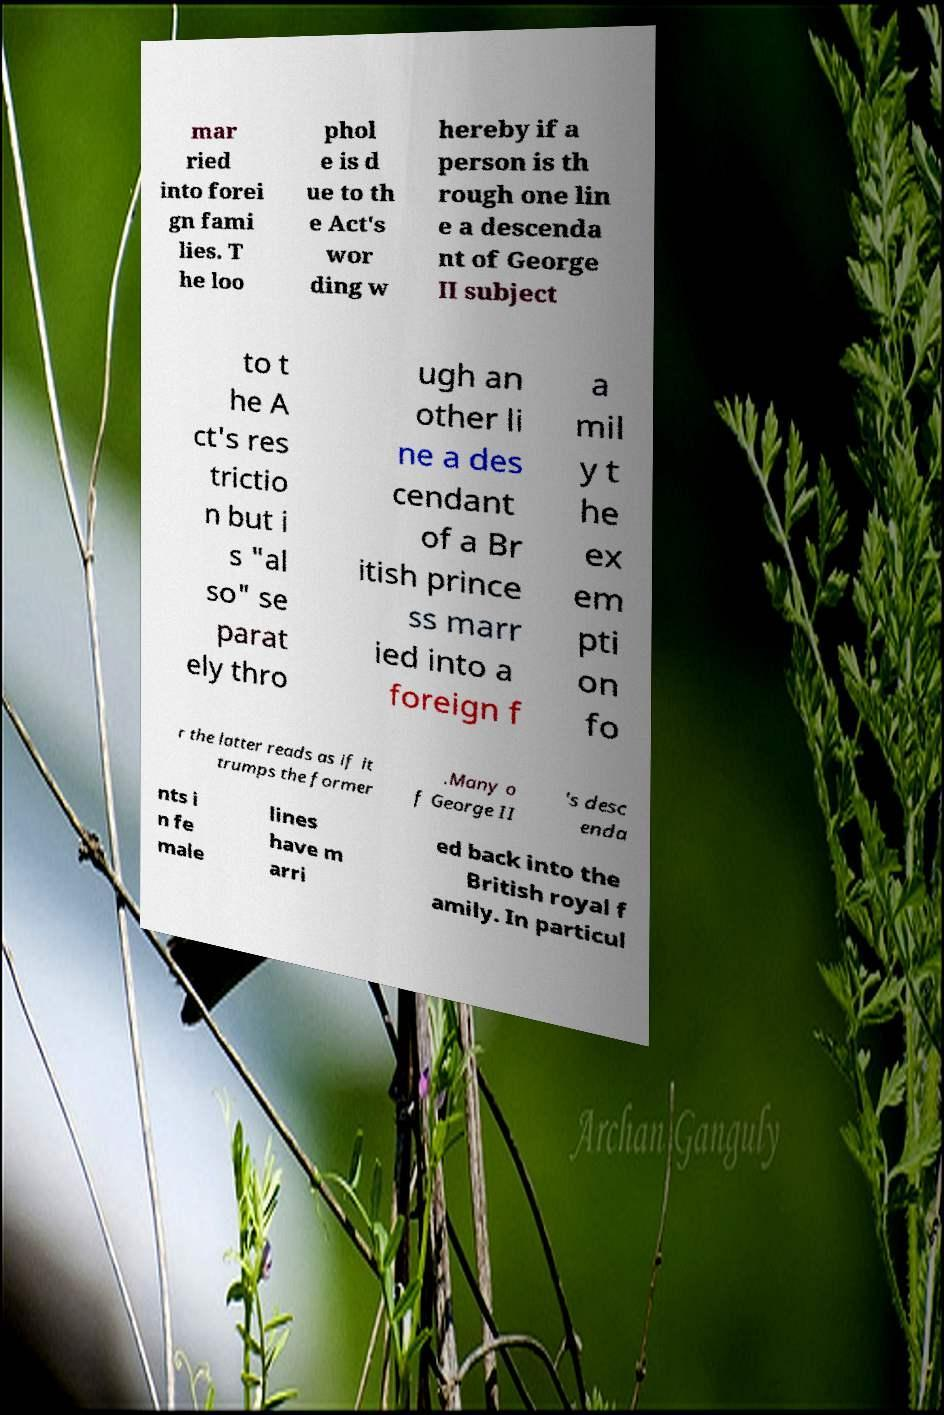Please read and relay the text visible in this image. What does it say? mar ried into forei gn fami lies. T he loo phol e is d ue to th e Act's wor ding w hereby if a person is th rough one lin e a descenda nt of George II subject to t he A ct's res trictio n but i s "al so" se parat ely thro ugh an other li ne a des cendant of a Br itish prince ss marr ied into a foreign f a mil y t he ex em pti on fo r the latter reads as if it trumps the former .Many o f George II 's desc enda nts i n fe male lines have m arri ed back into the British royal f amily. In particul 